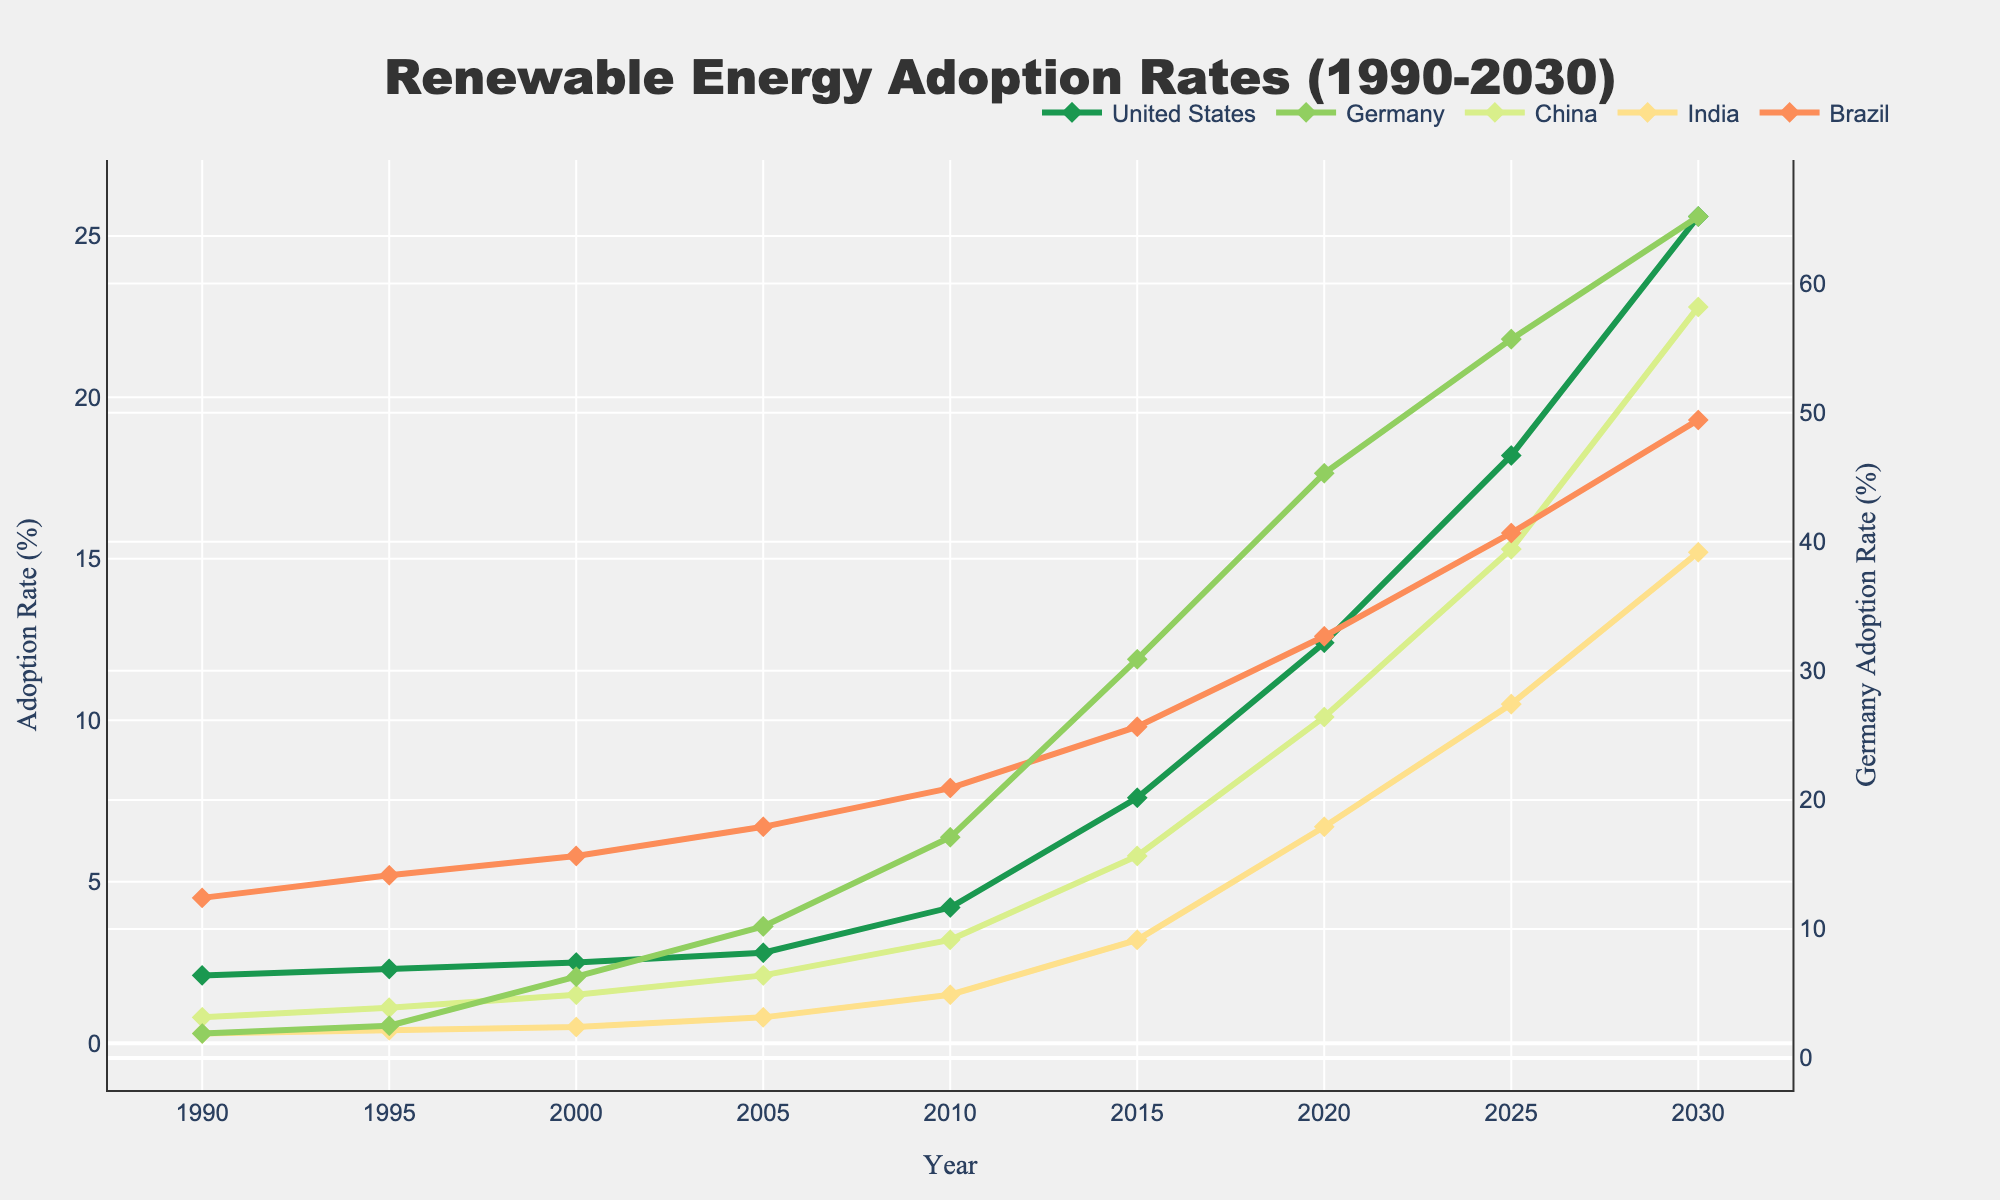what is the overall trend in renewable energy adoption rates for all the countries from 1990 to 2030? The lines for all countries show an upward trend over the years, indicating that renewable energy adoption rates are increasing in each country from 1990 to 2030.
Answer: Upward trend Which country had the steepest increase in renewable energy adoption rate between 2000 and 2020? By looking at the slopes of the lines between 2000 and 2020, Germany's line has the steepest slope, indicating the largest increase in renewable energy adoption rate during this period.
Answer: Germany How does Brazil's renewable energy adoption rate in 2010 compare to China's adoption rate in the same year? In 2010, Brazil's adoption rate is about 7.9%, while China's adoption rate is approximately 3.2%. Therefore, Brazil's rate is higher than China's.
Answer: Brazil's rate is higher What is the total renewable energy adoption rate of Germany, India, and Brazil in 2030? Sum up the adoption rates of Germany (65.2%), India (15.2%), and Brazil (19.3%) in 2030. 65.2 + 15.2 + 19.3 = 99.7%.
Answer: 99.7% By what percentage did the United States' renewable energy adoption rate change from 2015 to 2020? Subtract the adoption rate in 2015 (7.6%) from the rate in 2020 (12.4%) and divide by the 2015 rate, then multiply by 100. ((12.4 - 7.6)/7.6) * 100 = 63.16%.
Answer: 63.16% In which year did Germany surpass a 20% renewable energy adoption rate? The line for Germany crosses the 20% mark between 2005 and 2010, so in 2010, Germany's adoption rate is 17.1%, which is the first year it surpasses 20%.
Answer: 2010 Compare the renewable energy adoption rates of India and Brazil in 2025. Which country has a higher rate? In 2025, India's adoption rate is 10.5%, while Brazil's is 15.8%. Therefore, Brazil has a higher adoption rate.
Answer: Brazil What is the average renewable energy adoption rate for the United States from 1990 to 2030? Add up all the adoption rates for the United States for each year provided (2.1 + 2.3 + 2.5 + 2.8 + 4.2 + 7.6 + 12.4 + 18.2 + 25.6 = 77.7) and divide by the number of years (9). 77.7/9 ≈ 8.63%.
Answer: 8.63% How many countries have a renewable energy adoption rate exceeding 10% in 2020? Check the adoption rates for each country in 2020: United States (12.4%), Germany (45.3%), China (10.1%), India (6.7%), Brazil (12.6%). Three countries exceed 10%: United States, Germany, and Brazil.
Answer: 3 What is the difference in renewable energy adoption rates between China and India in 2030? Subtract India's adoption rate in 2030 (15.2%) from China's adoption rate in 2030 (22.8%). 22.8 - 15.2 = 7.6%.
Answer: 7.6% 